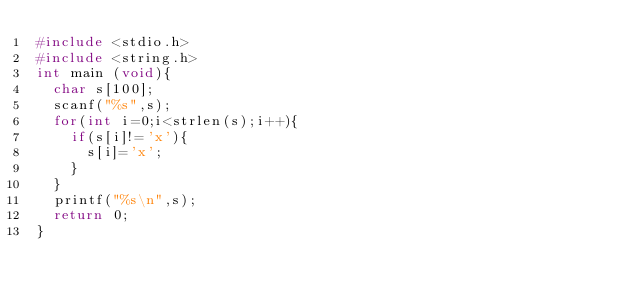<code> <loc_0><loc_0><loc_500><loc_500><_C_>#include <stdio.h>
#include <string.h>
int main (void){
  char s[100];
  scanf("%s",s);
  for(int i=0;i<strlen(s);i++){
    if(s[i]!='x'){
      s[i]='x';
    }
  }
  printf("%s\n",s);
  return 0;
}
</code> 